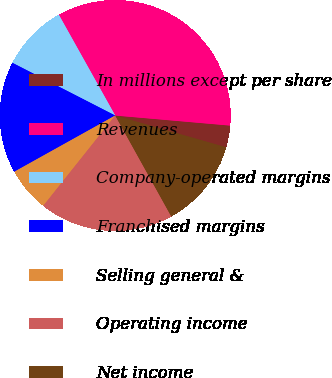Convert chart. <chart><loc_0><loc_0><loc_500><loc_500><pie_chart><fcel>In millions except per share<fcel>Revenues<fcel>Company-operated margins<fcel>Franchised margins<fcel>Selling general &<fcel>Operating income<fcel>Net income<nl><fcel>3.05%<fcel>34.51%<fcel>9.34%<fcel>15.63%<fcel>6.2%<fcel>18.78%<fcel>12.49%<nl></chart> 